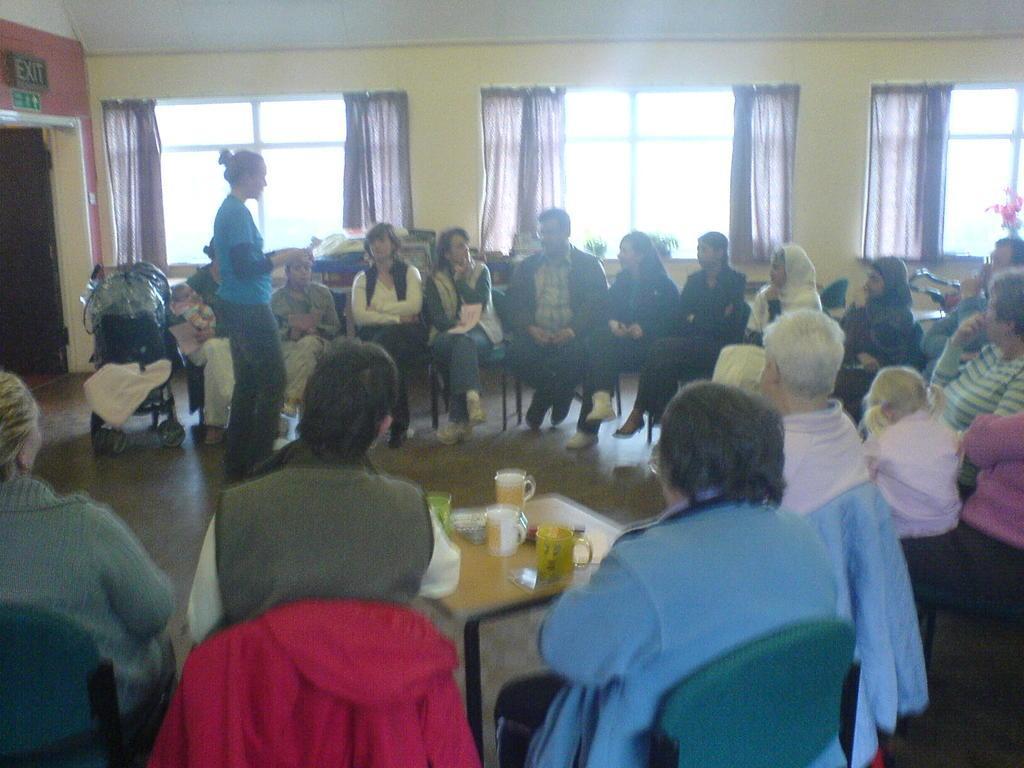Can you describe this image briefly? In the picture we can see a hall with some people sitting on the chairs and middle of them, we can see a woman standing and talking and near to her we can see a table and on it we can see some cups, jugs and in the background we can see a wall with windows and curtains to it. 